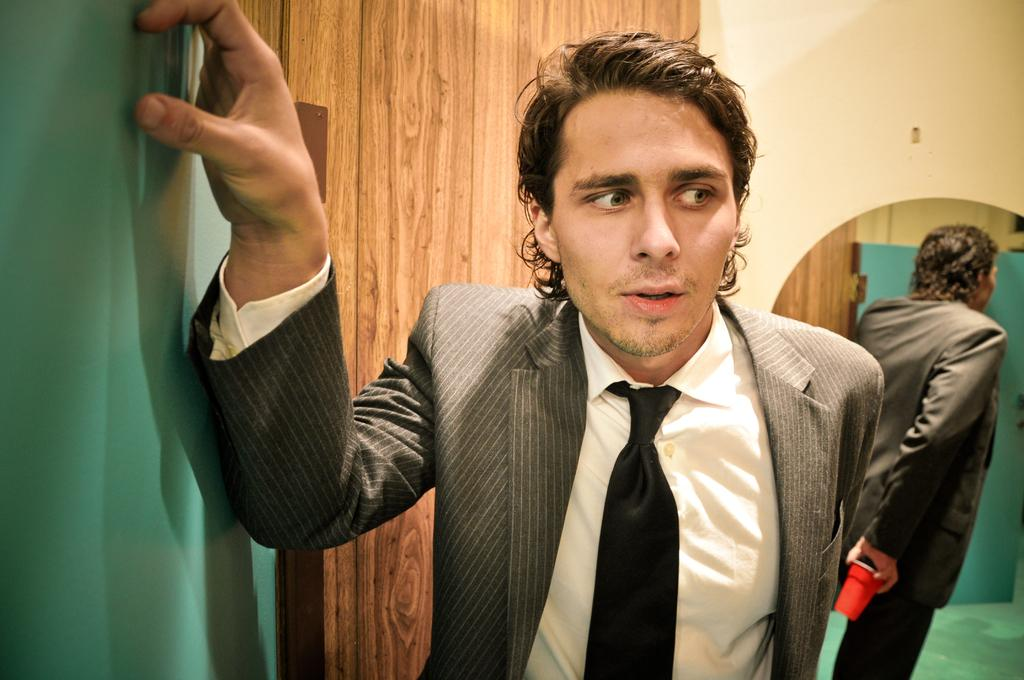What is the main subject of the image? There is a man standing in the image. What is behind the man in the image? There is a wooden surface behind the man. What can be seen in the background of the image? There is a wall and a mirror in the background of the image. What is the person in the mirror doing? The person in the mirror is standing and holding a glass. What type of cork can be seen on the man's head in the image? There is no cork present on the man's head in the image. How many owls are sitting on the wooden surface behind the man? There are no owls visible on the wooden surface behind the man in the image. 